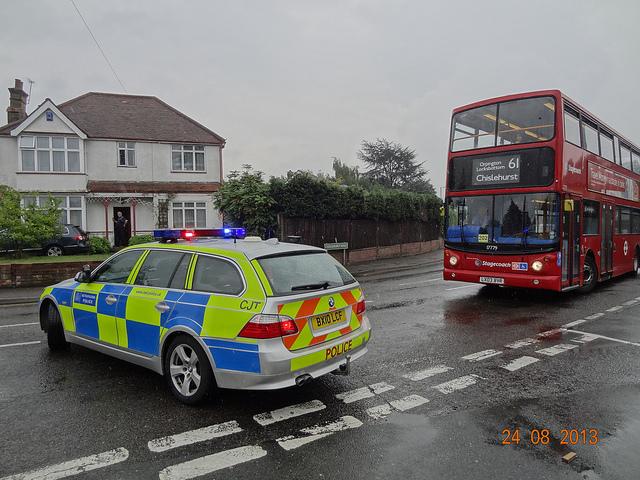Is the red vehicle a tricycle?
Quick response, please. No. Who does the car belong to?
Keep it brief. Police. Are the police stopping the bus for some reason?
Quick response, please. Yes. 